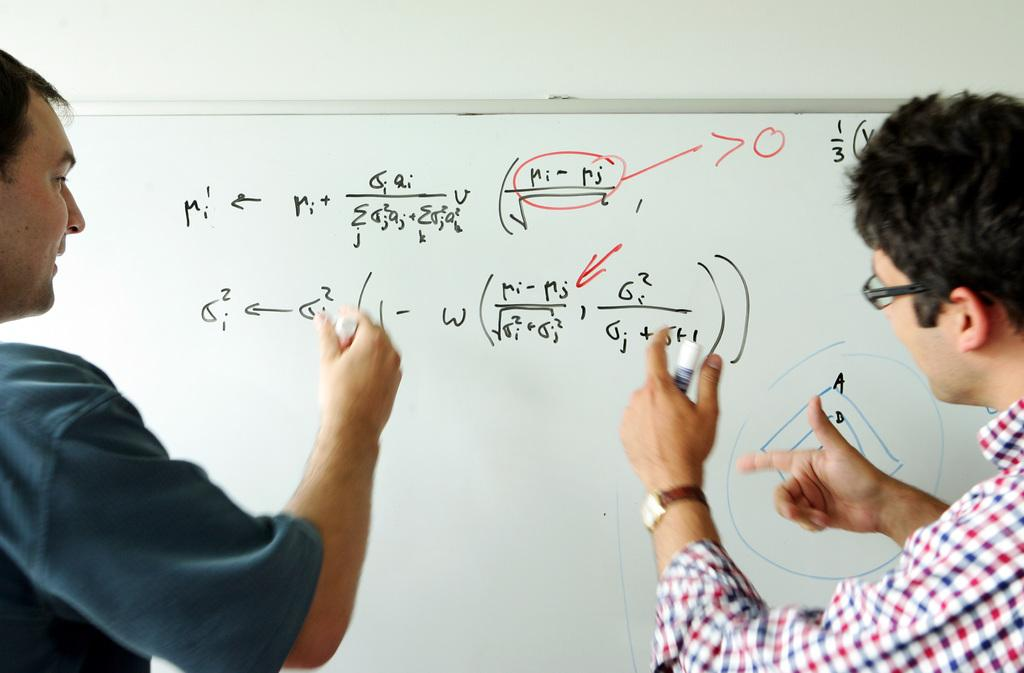<image>
Provide a brief description of the given image. Two men standing in front of a white marker board doing math equations. 